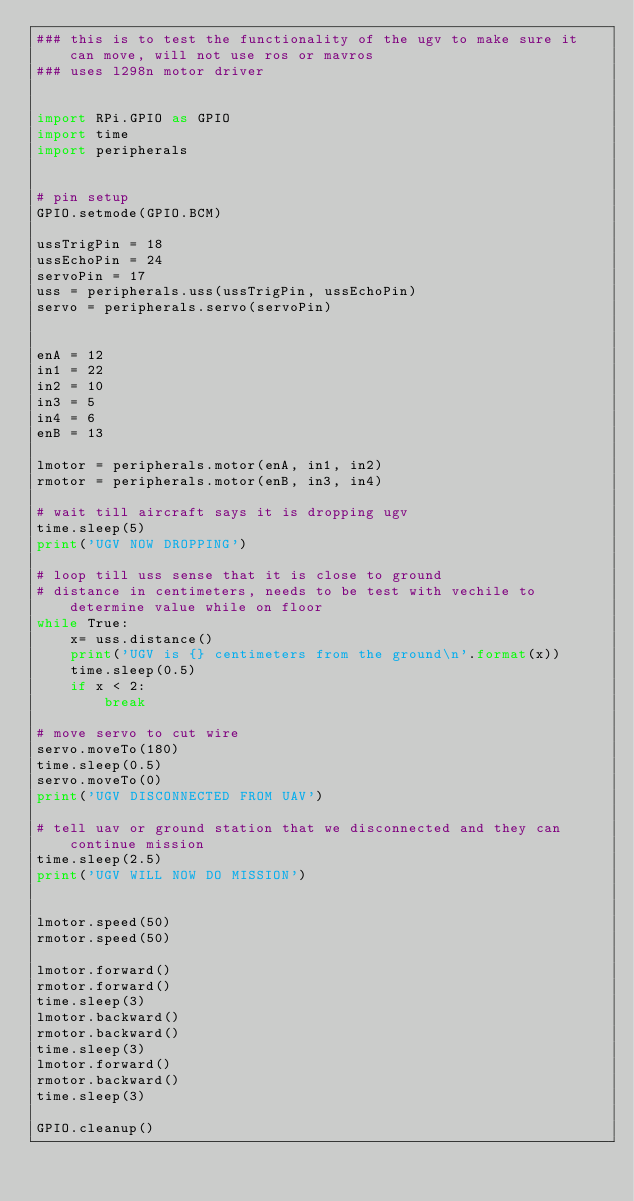<code> <loc_0><loc_0><loc_500><loc_500><_Python_>### this is to test the functionality of the ugv to make sure it can move, will not use ros or mavros
### uses l298n motor driver


import RPi.GPIO as GPIO
import time
import peripherals


# pin setup
GPIO.setmode(GPIO.BCM)

ussTrigPin = 18
ussEchoPin = 24 
servoPin = 17
uss = peripherals.uss(ussTrigPin, ussEchoPin)
servo = peripherals.servo(servoPin)


enA = 12
in1 = 22
in2 = 10
in3 = 5
in4 = 6
enB = 13

lmotor = peripherals.motor(enA, in1, in2)
rmotor = peripherals.motor(enB, in3, in4)

# wait till aircraft says it is dropping ugv
time.sleep(5)
print('UGV NOW DROPPING')

# loop till uss sense that it is close to ground
# distance in centimeters, needs to be test with vechile to determine value while on floor
while True:
    x= uss.distance()
    print('UGV is {} centimeters from the ground\n'.format(x))
    time.sleep(0.5)
    if x < 2:
        break

# move servo to cut wire
servo.moveTo(180)
time.sleep(0.5)
servo.moveTo(0)
print('UGV DISCONNECTED FROM UAV')

# tell uav or ground station that we disconnected and they can continue mission
time.sleep(2.5)
print('UGV WILL NOW DO MISSION')


lmotor.speed(50)
rmotor.speed(50)

lmotor.forward()
rmotor.forward()
time.sleep(3)
lmotor.backward()
rmotor.backward()
time.sleep(3)
lmotor.forward()
rmotor.backward()
time.sleep(3)

GPIO.cleanup()</code> 